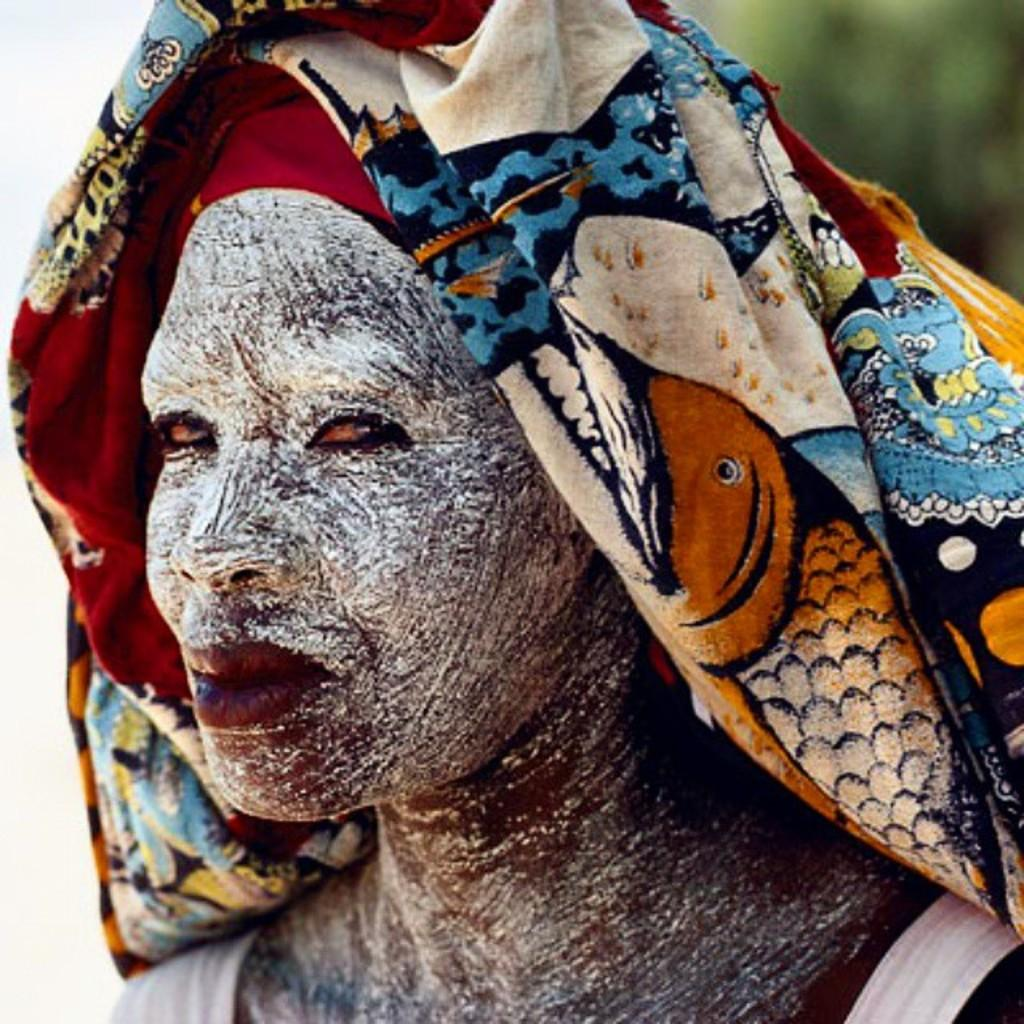What is the main subject of the image? There is a person in the image. What is the person wearing? The person is wearing a white dress. What can be seen on the person's face? The person has a white painting on their face. What is covering the person's head? There is a cloth on the person's head. How would you describe the background of the image? The background of the image is blurry. What type of crate is being used to store the writing in the image? There is no crate or writing present in the image. 